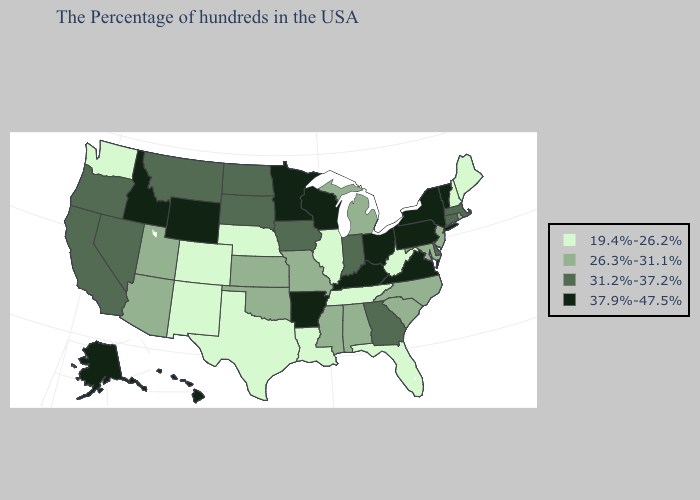Among the states that border Missouri , which have the lowest value?
Answer briefly. Tennessee, Illinois, Nebraska. Name the states that have a value in the range 37.9%-47.5%?
Short answer required. Vermont, New York, Pennsylvania, Virginia, Ohio, Kentucky, Wisconsin, Arkansas, Minnesota, Wyoming, Idaho, Alaska, Hawaii. Does Hawaii have a higher value than Iowa?
Concise answer only. Yes. Does Rhode Island have the lowest value in the Northeast?
Give a very brief answer. No. What is the value of Nevada?
Concise answer only. 31.2%-37.2%. Name the states that have a value in the range 19.4%-26.2%?
Concise answer only. Maine, New Hampshire, West Virginia, Florida, Tennessee, Illinois, Louisiana, Nebraska, Texas, Colorado, New Mexico, Washington. Name the states that have a value in the range 26.3%-31.1%?
Short answer required. Rhode Island, New Jersey, Maryland, North Carolina, South Carolina, Michigan, Alabama, Mississippi, Missouri, Kansas, Oklahoma, Utah, Arizona. What is the value of South Carolina?
Quick response, please. 26.3%-31.1%. What is the value of Tennessee?
Concise answer only. 19.4%-26.2%. Which states have the lowest value in the USA?
Quick response, please. Maine, New Hampshire, West Virginia, Florida, Tennessee, Illinois, Louisiana, Nebraska, Texas, Colorado, New Mexico, Washington. Name the states that have a value in the range 19.4%-26.2%?
Write a very short answer. Maine, New Hampshire, West Virginia, Florida, Tennessee, Illinois, Louisiana, Nebraska, Texas, Colorado, New Mexico, Washington. What is the lowest value in the USA?
Answer briefly. 19.4%-26.2%. Does Hawaii have a lower value than South Dakota?
Keep it brief. No. What is the value of Minnesota?
Be succinct. 37.9%-47.5%. Name the states that have a value in the range 19.4%-26.2%?
Quick response, please. Maine, New Hampshire, West Virginia, Florida, Tennessee, Illinois, Louisiana, Nebraska, Texas, Colorado, New Mexico, Washington. 